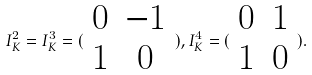Convert formula to latex. <formula><loc_0><loc_0><loc_500><loc_500>I _ { K } ^ { 2 } = I _ { K } ^ { 3 } = ( \begin{array} { c c } 0 & - 1 \\ 1 & 0 \end{array} ) , I _ { K } ^ { 4 } = ( \begin{array} { c c } 0 & 1 \\ 1 & 0 \end{array} ) .</formula> 